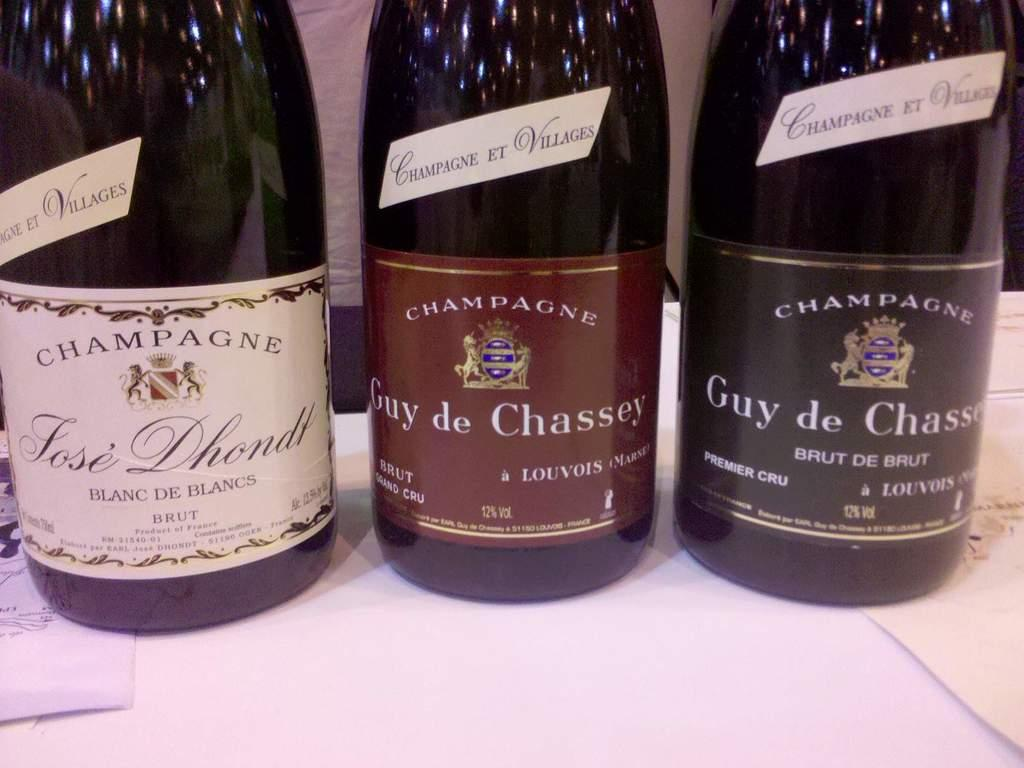How many bottles are visible in the image? There are 3 bottles in the image. What color are the bottles in the image? The bottles are black in color. Can you tell me how many cats are swimming in the image? There are no cats or any swimming activity present in the image. 